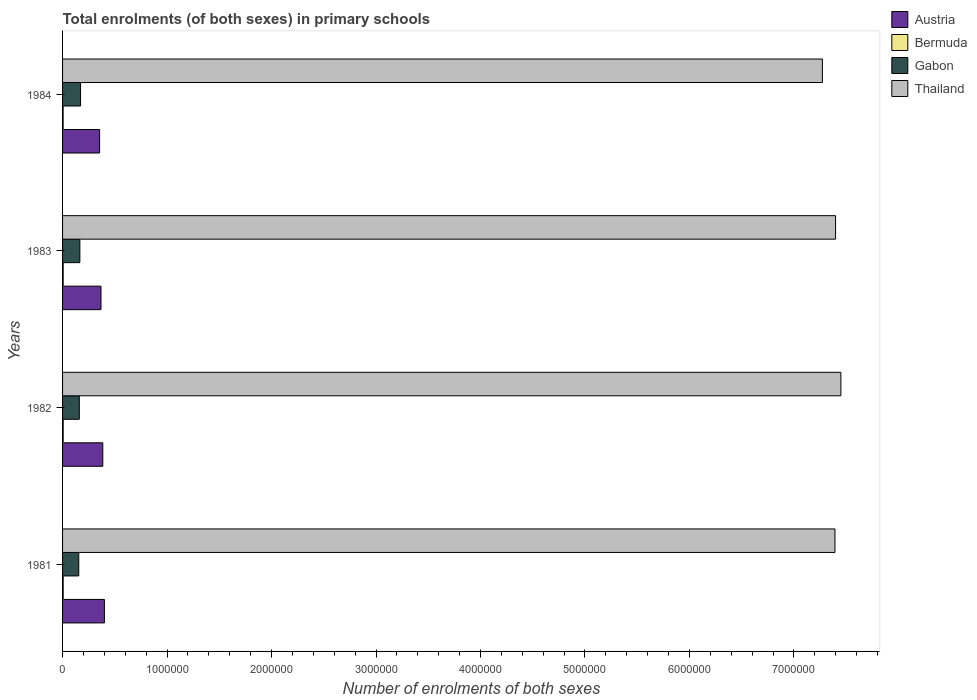How many different coloured bars are there?
Offer a terse response. 4. How many bars are there on the 1st tick from the top?
Your answer should be compact. 4. How many bars are there on the 2nd tick from the bottom?
Give a very brief answer. 4. What is the label of the 3rd group of bars from the top?
Provide a short and direct response. 1982. What is the number of enrolments in primary schools in Austria in 1984?
Make the answer very short. 3.54e+05. Across all years, what is the maximum number of enrolments in primary schools in Thailand?
Offer a very short reply. 7.45e+06. Across all years, what is the minimum number of enrolments in primary schools in Bermuda?
Make the answer very short. 5530. In which year was the number of enrolments in primary schools in Bermuda maximum?
Provide a short and direct response. 1981. What is the total number of enrolments in primary schools in Thailand in the graph?
Your answer should be compact. 2.95e+07. What is the difference between the number of enrolments in primary schools in Austria in 1981 and that in 1983?
Give a very brief answer. 3.27e+04. What is the difference between the number of enrolments in primary schools in Bermuda in 1982 and the number of enrolments in primary schools in Thailand in 1984?
Give a very brief answer. -7.27e+06. What is the average number of enrolments in primary schools in Austria per year?
Keep it short and to the point. 3.77e+05. In the year 1984, what is the difference between the number of enrolments in primary schools in Thailand and number of enrolments in primary schools in Bermuda?
Provide a succinct answer. 7.27e+06. What is the ratio of the number of enrolments in primary schools in Bermuda in 1981 to that in 1982?
Keep it short and to the point. 1.01. What is the difference between the highest and the second highest number of enrolments in primary schools in Austria?
Provide a short and direct response. 1.54e+04. What is the difference between the highest and the lowest number of enrolments in primary schools in Austria?
Provide a short and direct response. 4.59e+04. Is the sum of the number of enrolments in primary schools in Thailand in 1981 and 1982 greater than the maximum number of enrolments in primary schools in Austria across all years?
Keep it short and to the point. Yes. Is it the case that in every year, the sum of the number of enrolments in primary schools in Gabon and number of enrolments in primary schools in Bermuda is greater than the sum of number of enrolments in primary schools in Thailand and number of enrolments in primary schools in Austria?
Your answer should be very brief. Yes. What does the 4th bar from the top in 1984 represents?
Make the answer very short. Austria. What does the 4th bar from the bottom in 1981 represents?
Make the answer very short. Thailand. Are all the bars in the graph horizontal?
Ensure brevity in your answer.  Yes. How many years are there in the graph?
Give a very brief answer. 4. What is the difference between two consecutive major ticks on the X-axis?
Make the answer very short. 1.00e+06. Does the graph contain grids?
Offer a very short reply. No. Where does the legend appear in the graph?
Offer a very short reply. Top right. What is the title of the graph?
Give a very brief answer. Total enrolments (of both sexes) in primary schools. Does "Pacific island small states" appear as one of the legend labels in the graph?
Offer a very short reply. No. What is the label or title of the X-axis?
Make the answer very short. Number of enrolments of both sexes. What is the Number of enrolments of both sexes of Austria in 1981?
Provide a short and direct response. 4.00e+05. What is the Number of enrolments of both sexes of Bermuda in 1981?
Provide a succinct answer. 5934. What is the Number of enrolments of both sexes in Gabon in 1981?
Your answer should be very brief. 1.55e+05. What is the Number of enrolments of both sexes in Thailand in 1981?
Make the answer very short. 7.39e+06. What is the Number of enrolments of both sexes of Austria in 1982?
Keep it short and to the point. 3.85e+05. What is the Number of enrolments of both sexes in Bermuda in 1982?
Your answer should be very brief. 5881. What is the Number of enrolments of both sexes in Gabon in 1982?
Your answer should be compact. 1.60e+05. What is the Number of enrolments of both sexes of Thailand in 1982?
Ensure brevity in your answer.  7.45e+06. What is the Number of enrolments of both sexes in Austria in 1983?
Offer a terse response. 3.68e+05. What is the Number of enrolments of both sexes of Bermuda in 1983?
Give a very brief answer. 5750. What is the Number of enrolments of both sexes of Gabon in 1983?
Ensure brevity in your answer.  1.66e+05. What is the Number of enrolments of both sexes in Thailand in 1983?
Provide a short and direct response. 7.40e+06. What is the Number of enrolments of both sexes of Austria in 1984?
Provide a succinct answer. 3.54e+05. What is the Number of enrolments of both sexes of Bermuda in 1984?
Your answer should be very brief. 5530. What is the Number of enrolments of both sexes of Gabon in 1984?
Your answer should be very brief. 1.72e+05. What is the Number of enrolments of both sexes in Thailand in 1984?
Ensure brevity in your answer.  7.27e+06. Across all years, what is the maximum Number of enrolments of both sexes of Austria?
Provide a succinct answer. 4.00e+05. Across all years, what is the maximum Number of enrolments of both sexes in Bermuda?
Offer a very short reply. 5934. Across all years, what is the maximum Number of enrolments of both sexes of Gabon?
Give a very brief answer. 1.72e+05. Across all years, what is the maximum Number of enrolments of both sexes of Thailand?
Your answer should be very brief. 7.45e+06. Across all years, what is the minimum Number of enrolments of both sexes of Austria?
Provide a succinct answer. 3.54e+05. Across all years, what is the minimum Number of enrolments of both sexes of Bermuda?
Provide a succinct answer. 5530. Across all years, what is the minimum Number of enrolments of both sexes in Gabon?
Your answer should be compact. 1.55e+05. Across all years, what is the minimum Number of enrolments of both sexes in Thailand?
Provide a succinct answer. 7.27e+06. What is the total Number of enrolments of both sexes of Austria in the graph?
Your answer should be compact. 1.51e+06. What is the total Number of enrolments of both sexes of Bermuda in the graph?
Offer a very short reply. 2.31e+04. What is the total Number of enrolments of both sexes of Gabon in the graph?
Ensure brevity in your answer.  6.53e+05. What is the total Number of enrolments of both sexes in Thailand in the graph?
Provide a succinct answer. 2.95e+07. What is the difference between the Number of enrolments of both sexes of Austria in 1981 and that in 1982?
Keep it short and to the point. 1.54e+04. What is the difference between the Number of enrolments of both sexes of Gabon in 1981 and that in 1982?
Offer a terse response. -5268. What is the difference between the Number of enrolments of both sexes in Thailand in 1981 and that in 1982?
Provide a succinct answer. -5.67e+04. What is the difference between the Number of enrolments of both sexes in Austria in 1981 and that in 1983?
Provide a short and direct response. 3.27e+04. What is the difference between the Number of enrolments of both sexes in Bermuda in 1981 and that in 1983?
Your answer should be compact. 184. What is the difference between the Number of enrolments of both sexes of Gabon in 1981 and that in 1983?
Give a very brief answer. -1.05e+04. What is the difference between the Number of enrolments of both sexes of Thailand in 1981 and that in 1983?
Make the answer very short. -5621. What is the difference between the Number of enrolments of both sexes in Austria in 1981 and that in 1984?
Your response must be concise. 4.59e+04. What is the difference between the Number of enrolments of both sexes in Bermuda in 1981 and that in 1984?
Ensure brevity in your answer.  404. What is the difference between the Number of enrolments of both sexes of Gabon in 1981 and that in 1984?
Provide a short and direct response. -1.71e+04. What is the difference between the Number of enrolments of both sexes in Thailand in 1981 and that in 1984?
Offer a terse response. 1.20e+05. What is the difference between the Number of enrolments of both sexes of Austria in 1982 and that in 1983?
Your answer should be compact. 1.73e+04. What is the difference between the Number of enrolments of both sexes of Bermuda in 1982 and that in 1983?
Your answer should be compact. 131. What is the difference between the Number of enrolments of both sexes in Gabon in 1982 and that in 1983?
Your answer should be very brief. -5210. What is the difference between the Number of enrolments of both sexes in Thailand in 1982 and that in 1983?
Offer a terse response. 5.10e+04. What is the difference between the Number of enrolments of both sexes in Austria in 1982 and that in 1984?
Your answer should be compact. 3.05e+04. What is the difference between the Number of enrolments of both sexes of Bermuda in 1982 and that in 1984?
Ensure brevity in your answer.  351. What is the difference between the Number of enrolments of both sexes of Gabon in 1982 and that in 1984?
Provide a short and direct response. -1.19e+04. What is the difference between the Number of enrolments of both sexes of Thailand in 1982 and that in 1984?
Your response must be concise. 1.77e+05. What is the difference between the Number of enrolments of both sexes in Austria in 1983 and that in 1984?
Your answer should be very brief. 1.32e+04. What is the difference between the Number of enrolments of both sexes of Bermuda in 1983 and that in 1984?
Provide a short and direct response. 220. What is the difference between the Number of enrolments of both sexes of Gabon in 1983 and that in 1984?
Your answer should be compact. -6642. What is the difference between the Number of enrolments of both sexes of Thailand in 1983 and that in 1984?
Your response must be concise. 1.26e+05. What is the difference between the Number of enrolments of both sexes in Austria in 1981 and the Number of enrolments of both sexes in Bermuda in 1982?
Your answer should be compact. 3.95e+05. What is the difference between the Number of enrolments of both sexes of Austria in 1981 and the Number of enrolments of both sexes of Gabon in 1982?
Offer a very short reply. 2.40e+05. What is the difference between the Number of enrolments of both sexes in Austria in 1981 and the Number of enrolments of both sexes in Thailand in 1982?
Offer a very short reply. -7.05e+06. What is the difference between the Number of enrolments of both sexes in Bermuda in 1981 and the Number of enrolments of both sexes in Gabon in 1982?
Provide a succinct answer. -1.54e+05. What is the difference between the Number of enrolments of both sexes of Bermuda in 1981 and the Number of enrolments of both sexes of Thailand in 1982?
Your answer should be compact. -7.44e+06. What is the difference between the Number of enrolments of both sexes of Gabon in 1981 and the Number of enrolments of both sexes of Thailand in 1982?
Make the answer very short. -7.29e+06. What is the difference between the Number of enrolments of both sexes of Austria in 1981 and the Number of enrolments of both sexes of Bermuda in 1983?
Ensure brevity in your answer.  3.95e+05. What is the difference between the Number of enrolments of both sexes of Austria in 1981 and the Number of enrolments of both sexes of Gabon in 1983?
Your response must be concise. 2.35e+05. What is the difference between the Number of enrolments of both sexes in Austria in 1981 and the Number of enrolments of both sexes in Thailand in 1983?
Ensure brevity in your answer.  -7.00e+06. What is the difference between the Number of enrolments of both sexes in Bermuda in 1981 and the Number of enrolments of both sexes in Gabon in 1983?
Your answer should be compact. -1.60e+05. What is the difference between the Number of enrolments of both sexes in Bermuda in 1981 and the Number of enrolments of both sexes in Thailand in 1983?
Offer a terse response. -7.39e+06. What is the difference between the Number of enrolments of both sexes in Gabon in 1981 and the Number of enrolments of both sexes in Thailand in 1983?
Your answer should be compact. -7.24e+06. What is the difference between the Number of enrolments of both sexes in Austria in 1981 and the Number of enrolments of both sexes in Bermuda in 1984?
Ensure brevity in your answer.  3.95e+05. What is the difference between the Number of enrolments of both sexes of Austria in 1981 and the Number of enrolments of both sexes of Gabon in 1984?
Your answer should be compact. 2.28e+05. What is the difference between the Number of enrolments of both sexes of Austria in 1981 and the Number of enrolments of both sexes of Thailand in 1984?
Your answer should be compact. -6.87e+06. What is the difference between the Number of enrolments of both sexes in Bermuda in 1981 and the Number of enrolments of both sexes in Gabon in 1984?
Provide a short and direct response. -1.66e+05. What is the difference between the Number of enrolments of both sexes of Bermuda in 1981 and the Number of enrolments of both sexes of Thailand in 1984?
Make the answer very short. -7.27e+06. What is the difference between the Number of enrolments of both sexes in Gabon in 1981 and the Number of enrolments of both sexes in Thailand in 1984?
Offer a very short reply. -7.12e+06. What is the difference between the Number of enrolments of both sexes in Austria in 1982 and the Number of enrolments of both sexes in Bermuda in 1983?
Your answer should be compact. 3.79e+05. What is the difference between the Number of enrolments of both sexes in Austria in 1982 and the Number of enrolments of both sexes in Gabon in 1983?
Give a very brief answer. 2.19e+05. What is the difference between the Number of enrolments of both sexes in Austria in 1982 and the Number of enrolments of both sexes in Thailand in 1983?
Ensure brevity in your answer.  -7.01e+06. What is the difference between the Number of enrolments of both sexes of Bermuda in 1982 and the Number of enrolments of both sexes of Gabon in 1983?
Provide a succinct answer. -1.60e+05. What is the difference between the Number of enrolments of both sexes of Bermuda in 1982 and the Number of enrolments of both sexes of Thailand in 1983?
Provide a short and direct response. -7.39e+06. What is the difference between the Number of enrolments of both sexes in Gabon in 1982 and the Number of enrolments of both sexes in Thailand in 1983?
Provide a short and direct response. -7.24e+06. What is the difference between the Number of enrolments of both sexes of Austria in 1982 and the Number of enrolments of both sexes of Bermuda in 1984?
Your answer should be very brief. 3.79e+05. What is the difference between the Number of enrolments of both sexes in Austria in 1982 and the Number of enrolments of both sexes in Gabon in 1984?
Provide a short and direct response. 2.13e+05. What is the difference between the Number of enrolments of both sexes in Austria in 1982 and the Number of enrolments of both sexes in Thailand in 1984?
Keep it short and to the point. -6.89e+06. What is the difference between the Number of enrolments of both sexes of Bermuda in 1982 and the Number of enrolments of both sexes of Gabon in 1984?
Make the answer very short. -1.66e+05. What is the difference between the Number of enrolments of both sexes in Bermuda in 1982 and the Number of enrolments of both sexes in Thailand in 1984?
Your response must be concise. -7.27e+06. What is the difference between the Number of enrolments of both sexes in Gabon in 1982 and the Number of enrolments of both sexes in Thailand in 1984?
Make the answer very short. -7.11e+06. What is the difference between the Number of enrolments of both sexes of Austria in 1983 and the Number of enrolments of both sexes of Bermuda in 1984?
Make the answer very short. 3.62e+05. What is the difference between the Number of enrolments of both sexes in Austria in 1983 and the Number of enrolments of both sexes in Gabon in 1984?
Keep it short and to the point. 1.95e+05. What is the difference between the Number of enrolments of both sexes of Austria in 1983 and the Number of enrolments of both sexes of Thailand in 1984?
Keep it short and to the point. -6.90e+06. What is the difference between the Number of enrolments of both sexes of Bermuda in 1983 and the Number of enrolments of both sexes of Gabon in 1984?
Offer a very short reply. -1.66e+05. What is the difference between the Number of enrolments of both sexes of Bermuda in 1983 and the Number of enrolments of both sexes of Thailand in 1984?
Your answer should be very brief. -7.27e+06. What is the difference between the Number of enrolments of both sexes in Gabon in 1983 and the Number of enrolments of both sexes in Thailand in 1984?
Offer a terse response. -7.11e+06. What is the average Number of enrolments of both sexes of Austria per year?
Keep it short and to the point. 3.77e+05. What is the average Number of enrolments of both sexes of Bermuda per year?
Ensure brevity in your answer.  5773.75. What is the average Number of enrolments of both sexes of Gabon per year?
Offer a terse response. 1.63e+05. What is the average Number of enrolments of both sexes in Thailand per year?
Give a very brief answer. 7.38e+06. In the year 1981, what is the difference between the Number of enrolments of both sexes in Austria and Number of enrolments of both sexes in Bermuda?
Ensure brevity in your answer.  3.94e+05. In the year 1981, what is the difference between the Number of enrolments of both sexes of Austria and Number of enrolments of both sexes of Gabon?
Ensure brevity in your answer.  2.45e+05. In the year 1981, what is the difference between the Number of enrolments of both sexes of Austria and Number of enrolments of both sexes of Thailand?
Make the answer very short. -6.99e+06. In the year 1981, what is the difference between the Number of enrolments of both sexes in Bermuda and Number of enrolments of both sexes in Gabon?
Provide a short and direct response. -1.49e+05. In the year 1981, what is the difference between the Number of enrolments of both sexes in Bermuda and Number of enrolments of both sexes in Thailand?
Your answer should be compact. -7.39e+06. In the year 1981, what is the difference between the Number of enrolments of both sexes in Gabon and Number of enrolments of both sexes in Thailand?
Provide a succinct answer. -7.24e+06. In the year 1982, what is the difference between the Number of enrolments of both sexes in Austria and Number of enrolments of both sexes in Bermuda?
Ensure brevity in your answer.  3.79e+05. In the year 1982, what is the difference between the Number of enrolments of both sexes of Austria and Number of enrolments of both sexes of Gabon?
Your answer should be very brief. 2.25e+05. In the year 1982, what is the difference between the Number of enrolments of both sexes in Austria and Number of enrolments of both sexes in Thailand?
Your answer should be compact. -7.06e+06. In the year 1982, what is the difference between the Number of enrolments of both sexes of Bermuda and Number of enrolments of both sexes of Gabon?
Provide a succinct answer. -1.54e+05. In the year 1982, what is the difference between the Number of enrolments of both sexes of Bermuda and Number of enrolments of both sexes of Thailand?
Make the answer very short. -7.44e+06. In the year 1982, what is the difference between the Number of enrolments of both sexes of Gabon and Number of enrolments of both sexes of Thailand?
Ensure brevity in your answer.  -7.29e+06. In the year 1983, what is the difference between the Number of enrolments of both sexes in Austria and Number of enrolments of both sexes in Bermuda?
Provide a short and direct response. 3.62e+05. In the year 1983, what is the difference between the Number of enrolments of both sexes of Austria and Number of enrolments of both sexes of Gabon?
Your answer should be very brief. 2.02e+05. In the year 1983, what is the difference between the Number of enrolments of both sexes of Austria and Number of enrolments of both sexes of Thailand?
Provide a short and direct response. -7.03e+06. In the year 1983, what is the difference between the Number of enrolments of both sexes of Bermuda and Number of enrolments of both sexes of Gabon?
Provide a succinct answer. -1.60e+05. In the year 1983, what is the difference between the Number of enrolments of both sexes of Bermuda and Number of enrolments of both sexes of Thailand?
Offer a terse response. -7.39e+06. In the year 1983, what is the difference between the Number of enrolments of both sexes in Gabon and Number of enrolments of both sexes in Thailand?
Provide a short and direct response. -7.23e+06. In the year 1984, what is the difference between the Number of enrolments of both sexes in Austria and Number of enrolments of both sexes in Bermuda?
Offer a terse response. 3.49e+05. In the year 1984, what is the difference between the Number of enrolments of both sexes in Austria and Number of enrolments of both sexes in Gabon?
Your answer should be very brief. 1.82e+05. In the year 1984, what is the difference between the Number of enrolments of both sexes in Austria and Number of enrolments of both sexes in Thailand?
Offer a terse response. -6.92e+06. In the year 1984, what is the difference between the Number of enrolments of both sexes of Bermuda and Number of enrolments of both sexes of Gabon?
Make the answer very short. -1.67e+05. In the year 1984, what is the difference between the Number of enrolments of both sexes in Bermuda and Number of enrolments of both sexes in Thailand?
Provide a short and direct response. -7.27e+06. In the year 1984, what is the difference between the Number of enrolments of both sexes of Gabon and Number of enrolments of both sexes of Thailand?
Make the answer very short. -7.10e+06. What is the ratio of the Number of enrolments of both sexes of Bermuda in 1981 to that in 1982?
Provide a succinct answer. 1.01. What is the ratio of the Number of enrolments of both sexes in Gabon in 1981 to that in 1982?
Keep it short and to the point. 0.97. What is the ratio of the Number of enrolments of both sexes of Austria in 1981 to that in 1983?
Your response must be concise. 1.09. What is the ratio of the Number of enrolments of both sexes in Bermuda in 1981 to that in 1983?
Your response must be concise. 1.03. What is the ratio of the Number of enrolments of both sexes of Gabon in 1981 to that in 1983?
Make the answer very short. 0.94. What is the ratio of the Number of enrolments of both sexes of Austria in 1981 to that in 1984?
Offer a very short reply. 1.13. What is the ratio of the Number of enrolments of both sexes of Bermuda in 1981 to that in 1984?
Provide a short and direct response. 1.07. What is the ratio of the Number of enrolments of both sexes of Gabon in 1981 to that in 1984?
Make the answer very short. 0.9. What is the ratio of the Number of enrolments of both sexes in Thailand in 1981 to that in 1984?
Your response must be concise. 1.02. What is the ratio of the Number of enrolments of both sexes in Austria in 1982 to that in 1983?
Provide a succinct answer. 1.05. What is the ratio of the Number of enrolments of both sexes of Bermuda in 1982 to that in 1983?
Give a very brief answer. 1.02. What is the ratio of the Number of enrolments of both sexes of Gabon in 1982 to that in 1983?
Your response must be concise. 0.97. What is the ratio of the Number of enrolments of both sexes of Thailand in 1982 to that in 1983?
Provide a short and direct response. 1.01. What is the ratio of the Number of enrolments of both sexes in Austria in 1982 to that in 1984?
Offer a terse response. 1.09. What is the ratio of the Number of enrolments of both sexes of Bermuda in 1982 to that in 1984?
Offer a terse response. 1.06. What is the ratio of the Number of enrolments of both sexes of Gabon in 1982 to that in 1984?
Ensure brevity in your answer.  0.93. What is the ratio of the Number of enrolments of both sexes in Thailand in 1982 to that in 1984?
Provide a succinct answer. 1.02. What is the ratio of the Number of enrolments of both sexes in Austria in 1983 to that in 1984?
Provide a succinct answer. 1.04. What is the ratio of the Number of enrolments of both sexes in Bermuda in 1983 to that in 1984?
Your response must be concise. 1.04. What is the ratio of the Number of enrolments of both sexes in Gabon in 1983 to that in 1984?
Offer a terse response. 0.96. What is the ratio of the Number of enrolments of both sexes in Thailand in 1983 to that in 1984?
Your response must be concise. 1.02. What is the difference between the highest and the second highest Number of enrolments of both sexes of Austria?
Keep it short and to the point. 1.54e+04. What is the difference between the highest and the second highest Number of enrolments of both sexes in Bermuda?
Provide a succinct answer. 53. What is the difference between the highest and the second highest Number of enrolments of both sexes of Gabon?
Your response must be concise. 6642. What is the difference between the highest and the second highest Number of enrolments of both sexes of Thailand?
Your answer should be very brief. 5.10e+04. What is the difference between the highest and the lowest Number of enrolments of both sexes of Austria?
Provide a short and direct response. 4.59e+04. What is the difference between the highest and the lowest Number of enrolments of both sexes of Bermuda?
Give a very brief answer. 404. What is the difference between the highest and the lowest Number of enrolments of both sexes of Gabon?
Keep it short and to the point. 1.71e+04. What is the difference between the highest and the lowest Number of enrolments of both sexes in Thailand?
Keep it short and to the point. 1.77e+05. 